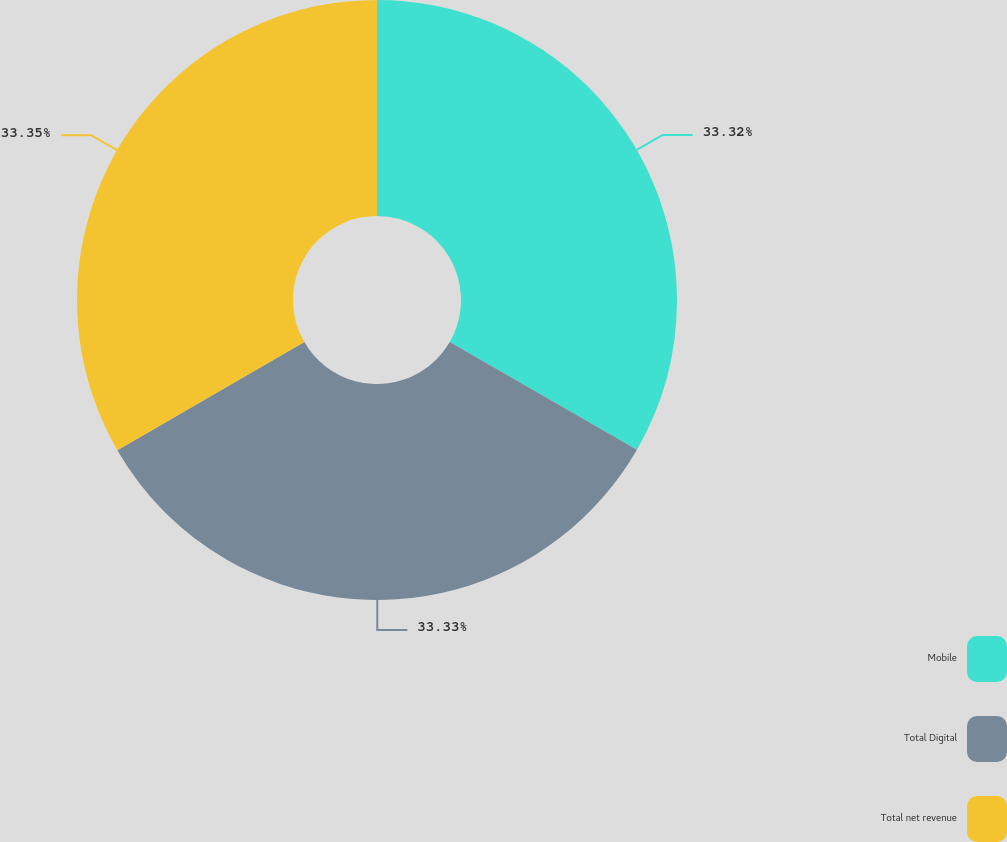Convert chart. <chart><loc_0><loc_0><loc_500><loc_500><pie_chart><fcel>Mobile<fcel>Total Digital<fcel>Total net revenue<nl><fcel>33.32%<fcel>33.33%<fcel>33.35%<nl></chart> 